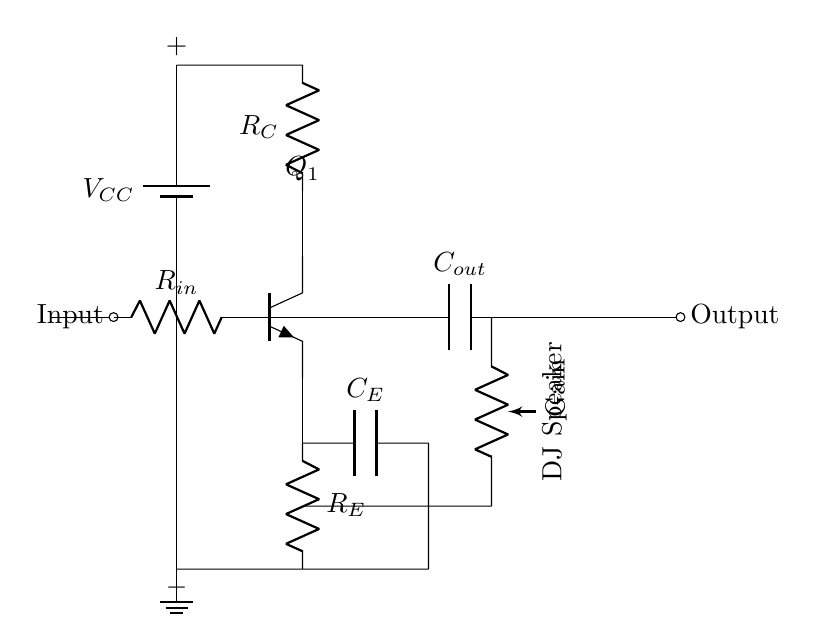What is the type of transistor used in this circuit? The transistor shown in the circuit is labeled as "Tnpn", indicating it is a bipolar junction transistor of type NPN.
Answer: NPN What is the function of the potentiometer labeled "Gain"? The potentiometer connected in the circuit allows for the adjustment of the gain, affecting how much the input signal is amplified before reaching the output.
Answer: Gain adjustment How many resistors are in this circuit? The circuit contains three resistors, labeled as R_in, R_C, and R_E, which influence the input impedance, the collector current, and the emitter biasing, respectively.
Answer: Three What component is used for output coupling? The output coupling capacitor labeled "C_out" is used to block any DC voltage at the output while allowing AC signals to pass through to the DJ speaker.
Answer: C_out What is the main purpose of the circuit? The main purpose of this power amplifier circuit is to amplify the audio signal sufficiently to drive DJ speakers, ensuring better sound quality and volume.
Answer: Amplifying audio signal What does the capacitor labeled "C_E" do? The capacitor "C_E" is connected in parallel with resistor R_E and acts as a bypass capacitor, enhancing AC gain by reducing the impact of R_E on the amplifier's performance.
Answer: Emitter bypass 